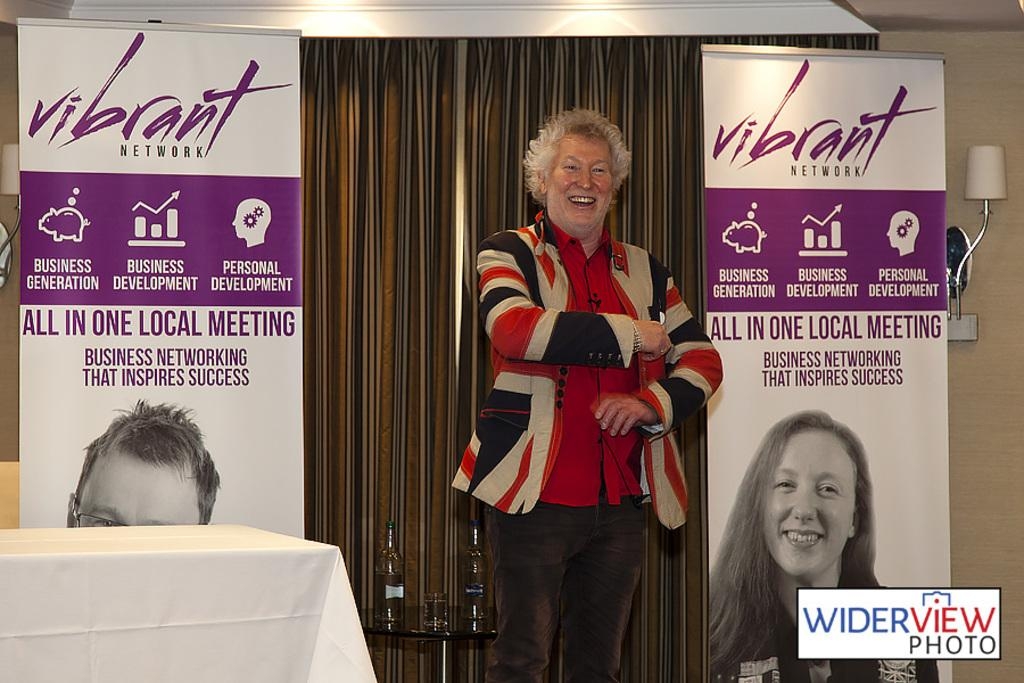What is the main subject in the image? There is a person standing in the image. What objects are on the table in the image? There are two bottles and a glass on the table. What can be seen in the background of the image? There is a board, a curtain, and a lamp attached to the wall in the background. How many snails are crawling on the person's shoulder in the image? There are no snails visible in the image; the person's shoulder is not shown. 